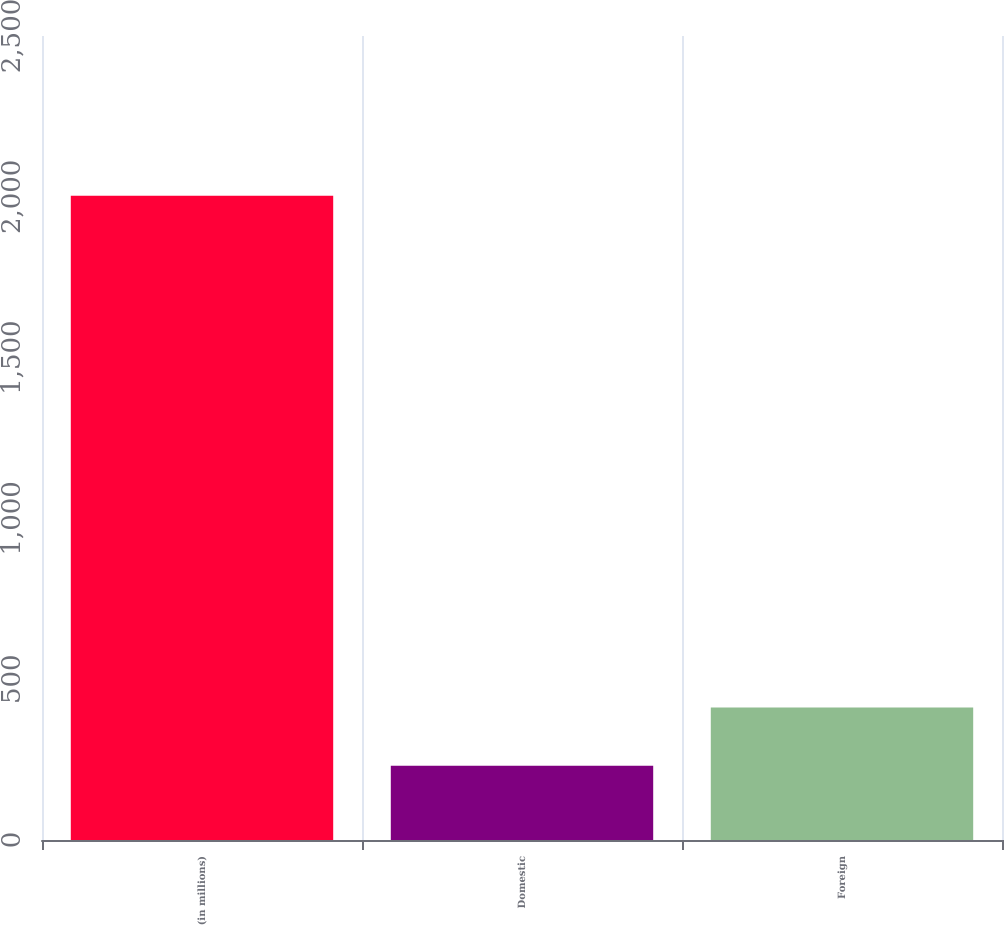<chart> <loc_0><loc_0><loc_500><loc_500><bar_chart><fcel>(in millions)<fcel>Domestic<fcel>Foreign<nl><fcel>2003<fcel>231<fcel>412<nl></chart> 